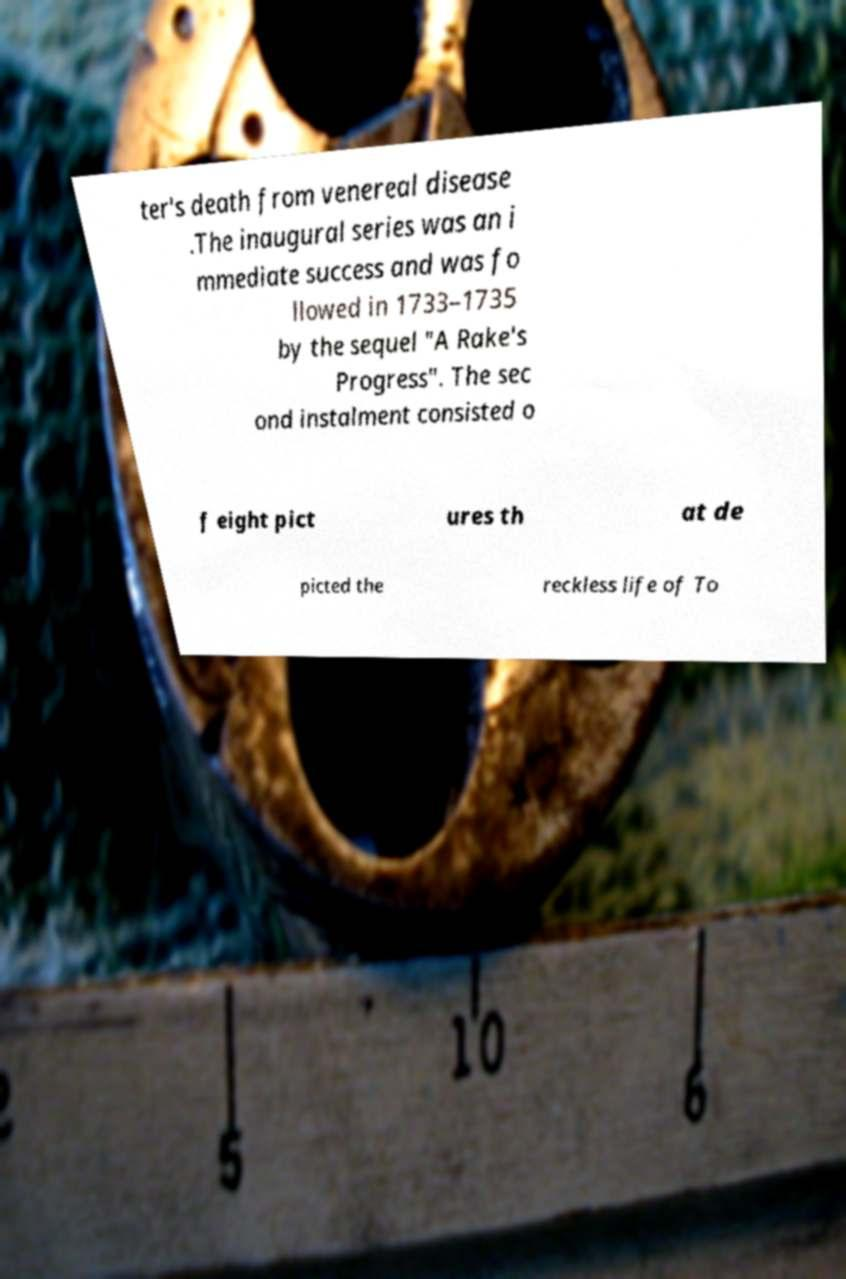There's text embedded in this image that I need extracted. Can you transcribe it verbatim? ter's death from venereal disease .The inaugural series was an i mmediate success and was fo llowed in 1733–1735 by the sequel "A Rake's Progress". The sec ond instalment consisted o f eight pict ures th at de picted the reckless life of To 